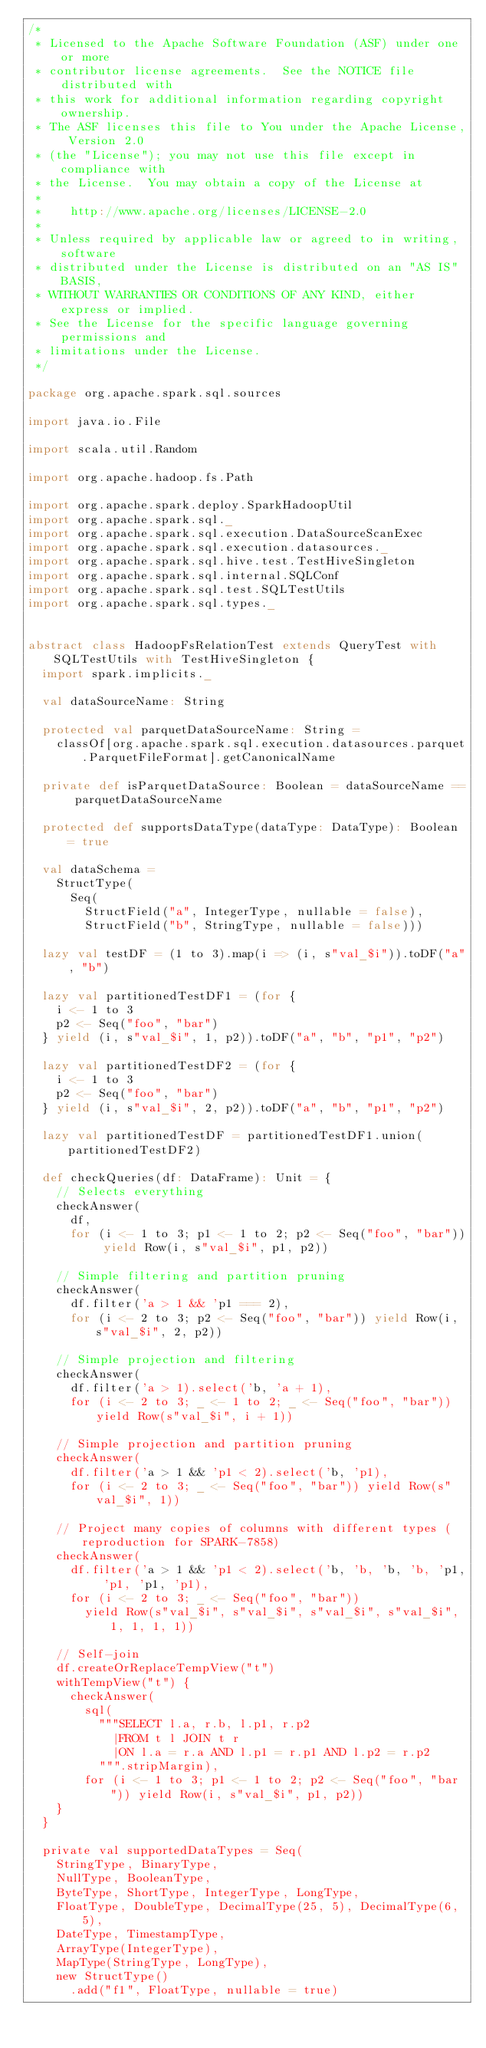Convert code to text. <code><loc_0><loc_0><loc_500><loc_500><_Scala_>/*
 * Licensed to the Apache Software Foundation (ASF) under one or more
 * contributor license agreements.  See the NOTICE file distributed with
 * this work for additional information regarding copyright ownership.
 * The ASF licenses this file to You under the Apache License, Version 2.0
 * (the "License"); you may not use this file except in compliance with
 * the License.  You may obtain a copy of the License at
 *
 *    http://www.apache.org/licenses/LICENSE-2.0
 *
 * Unless required by applicable law or agreed to in writing, software
 * distributed under the License is distributed on an "AS IS" BASIS,
 * WITHOUT WARRANTIES OR CONDITIONS OF ANY KIND, either express or implied.
 * See the License for the specific language governing permissions and
 * limitations under the License.
 */

package org.apache.spark.sql.sources

import java.io.File

import scala.util.Random

import org.apache.hadoop.fs.Path

import org.apache.spark.deploy.SparkHadoopUtil
import org.apache.spark.sql._
import org.apache.spark.sql.execution.DataSourceScanExec
import org.apache.spark.sql.execution.datasources._
import org.apache.spark.sql.hive.test.TestHiveSingleton
import org.apache.spark.sql.internal.SQLConf
import org.apache.spark.sql.test.SQLTestUtils
import org.apache.spark.sql.types._


abstract class HadoopFsRelationTest extends QueryTest with SQLTestUtils with TestHiveSingleton {
  import spark.implicits._

  val dataSourceName: String

  protected val parquetDataSourceName: String =
    classOf[org.apache.spark.sql.execution.datasources.parquet.ParquetFileFormat].getCanonicalName

  private def isParquetDataSource: Boolean = dataSourceName == parquetDataSourceName

  protected def supportsDataType(dataType: DataType): Boolean = true

  val dataSchema =
    StructType(
      Seq(
        StructField("a", IntegerType, nullable = false),
        StructField("b", StringType, nullable = false)))

  lazy val testDF = (1 to 3).map(i => (i, s"val_$i")).toDF("a", "b")

  lazy val partitionedTestDF1 = (for {
    i <- 1 to 3
    p2 <- Seq("foo", "bar")
  } yield (i, s"val_$i", 1, p2)).toDF("a", "b", "p1", "p2")

  lazy val partitionedTestDF2 = (for {
    i <- 1 to 3
    p2 <- Seq("foo", "bar")
  } yield (i, s"val_$i", 2, p2)).toDF("a", "b", "p1", "p2")

  lazy val partitionedTestDF = partitionedTestDF1.union(partitionedTestDF2)

  def checkQueries(df: DataFrame): Unit = {
    // Selects everything
    checkAnswer(
      df,
      for (i <- 1 to 3; p1 <- 1 to 2; p2 <- Seq("foo", "bar")) yield Row(i, s"val_$i", p1, p2))

    // Simple filtering and partition pruning
    checkAnswer(
      df.filter('a > 1 && 'p1 === 2),
      for (i <- 2 to 3; p2 <- Seq("foo", "bar")) yield Row(i, s"val_$i", 2, p2))

    // Simple projection and filtering
    checkAnswer(
      df.filter('a > 1).select('b, 'a + 1),
      for (i <- 2 to 3; _ <- 1 to 2; _ <- Seq("foo", "bar")) yield Row(s"val_$i", i + 1))

    // Simple projection and partition pruning
    checkAnswer(
      df.filter('a > 1 && 'p1 < 2).select('b, 'p1),
      for (i <- 2 to 3; _ <- Seq("foo", "bar")) yield Row(s"val_$i", 1))

    // Project many copies of columns with different types (reproduction for SPARK-7858)
    checkAnswer(
      df.filter('a > 1 && 'p1 < 2).select('b, 'b, 'b, 'b, 'p1, 'p1, 'p1, 'p1),
      for (i <- 2 to 3; _ <- Seq("foo", "bar"))
        yield Row(s"val_$i", s"val_$i", s"val_$i", s"val_$i", 1, 1, 1, 1))

    // Self-join
    df.createOrReplaceTempView("t")
    withTempView("t") {
      checkAnswer(
        sql(
          """SELECT l.a, r.b, l.p1, r.p2
            |FROM t l JOIN t r
            |ON l.a = r.a AND l.p1 = r.p1 AND l.p2 = r.p2
          """.stripMargin),
        for (i <- 1 to 3; p1 <- 1 to 2; p2 <- Seq("foo", "bar")) yield Row(i, s"val_$i", p1, p2))
    }
  }

  private val supportedDataTypes = Seq(
    StringType, BinaryType,
    NullType, BooleanType,
    ByteType, ShortType, IntegerType, LongType,
    FloatType, DoubleType, DecimalType(25, 5), DecimalType(6, 5),
    DateType, TimestampType,
    ArrayType(IntegerType),
    MapType(StringType, LongType),
    new StructType()
      .add("f1", FloatType, nullable = true)</code> 